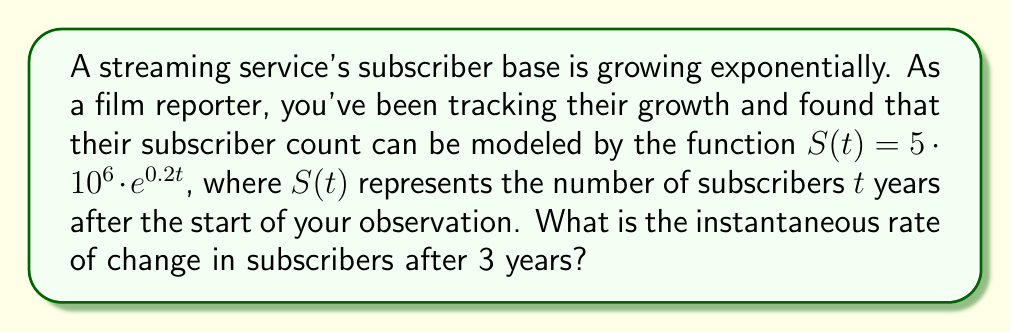Show me your answer to this math problem. To find the instantaneous rate of change, we need to calculate the derivative of the function $S(t)$ and evaluate it at $t=3$. Here's how we do it:

1) The given function is $S(t) = 5 \cdot 10^6 \cdot e^{0.2t}$

2) To find the derivative, we use the chain rule:
   $$\frac{d}{dt}[S(t)] = 5 \cdot 10^6 \cdot \frac{d}{dt}[e^{0.2t}]$$
   $$\frac{d}{dt}[S(t)] = 5 \cdot 10^6 \cdot 0.2 \cdot e^{0.2t}$$
   $$S'(t) = 10^6 \cdot e^{0.2t}$$

3) Now, we evaluate $S'(t)$ at $t=3$:
   $$S'(3) = 10^6 \cdot e^{0.2 \cdot 3}$$
   $$S'(3) = 10^6 \cdot e^{0.6}$$
   $$S'(3) = 10^6 \cdot 1.8221188...$$
   $$S'(3) \approx 1,822,119$$

This result represents the instantaneous rate of change in subscribers per year after 3 years.
Answer: The instantaneous rate of change in subscribers after 3 years is approximately 1,822,119 subscribers per year. 